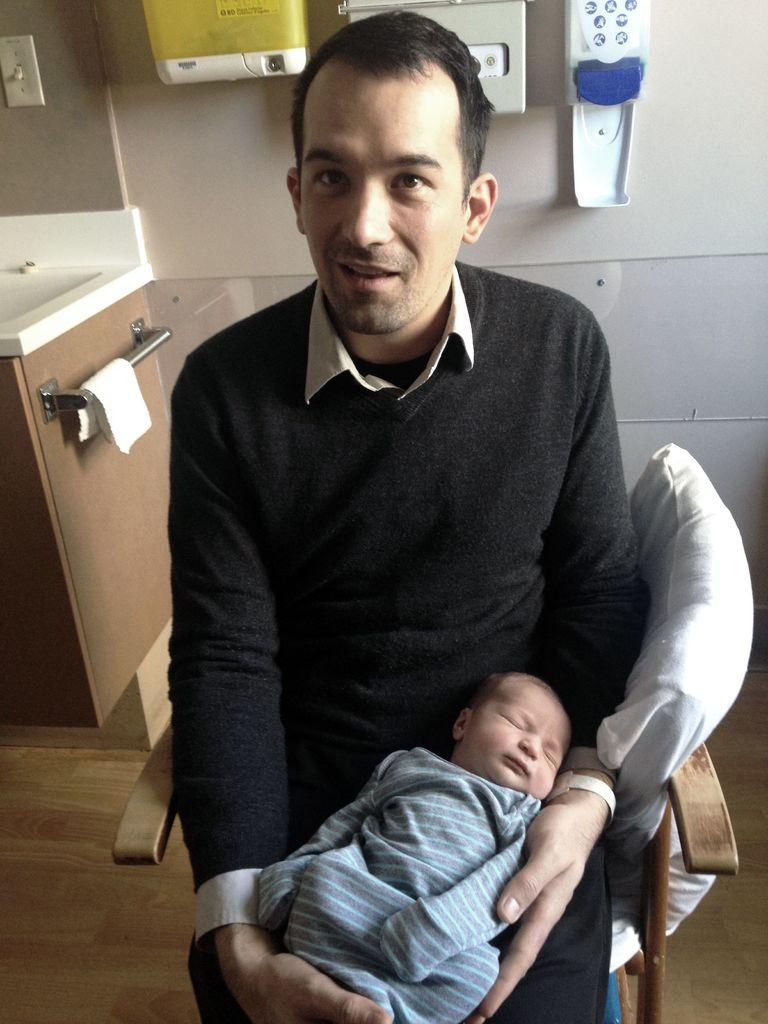What is the main subject of the image? There is a person in the image. What is the person doing in the image? The person is sitting on a chair and holding a baby. What type of fight is taking place in the image? There is no fight present in the image; it features a person sitting on a chair and holding a baby. What subject is the person teaching in the image? There is no teaching activity depicted in the image; the person is simply holding a baby. 